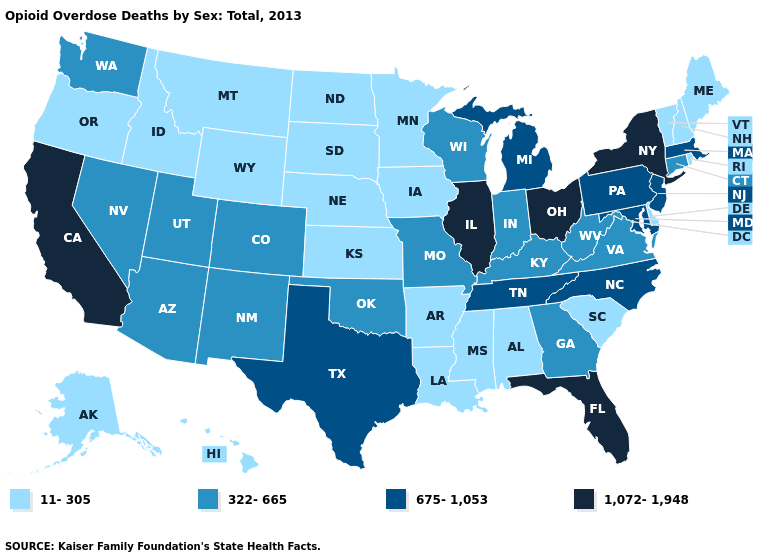Does California have the lowest value in the USA?
Give a very brief answer. No. Does Missouri have the same value as Nevada?
Quick response, please. Yes. What is the highest value in the USA?
Give a very brief answer. 1,072-1,948. Name the states that have a value in the range 1,072-1,948?
Give a very brief answer. California, Florida, Illinois, New York, Ohio. Is the legend a continuous bar?
Quick response, please. No. Name the states that have a value in the range 675-1,053?
Quick response, please. Maryland, Massachusetts, Michigan, New Jersey, North Carolina, Pennsylvania, Tennessee, Texas. Name the states that have a value in the range 1,072-1,948?
Be succinct. California, Florida, Illinois, New York, Ohio. Name the states that have a value in the range 675-1,053?
Write a very short answer. Maryland, Massachusetts, Michigan, New Jersey, North Carolina, Pennsylvania, Tennessee, Texas. Does California have the lowest value in the West?
Keep it brief. No. Does Arizona have the highest value in the USA?
Quick response, please. No. Name the states that have a value in the range 11-305?
Give a very brief answer. Alabama, Alaska, Arkansas, Delaware, Hawaii, Idaho, Iowa, Kansas, Louisiana, Maine, Minnesota, Mississippi, Montana, Nebraska, New Hampshire, North Dakota, Oregon, Rhode Island, South Carolina, South Dakota, Vermont, Wyoming. Among the states that border Nevada , which have the lowest value?
Be succinct. Idaho, Oregon. Name the states that have a value in the range 322-665?
Answer briefly. Arizona, Colorado, Connecticut, Georgia, Indiana, Kentucky, Missouri, Nevada, New Mexico, Oklahoma, Utah, Virginia, Washington, West Virginia, Wisconsin. Among the states that border Kentucky , which have the highest value?
Short answer required. Illinois, Ohio. Name the states that have a value in the range 675-1,053?
Concise answer only. Maryland, Massachusetts, Michigan, New Jersey, North Carolina, Pennsylvania, Tennessee, Texas. 